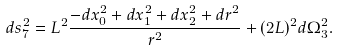Convert formula to latex. <formula><loc_0><loc_0><loc_500><loc_500>d s _ { 7 } ^ { 2 } = L ^ { 2 } \frac { - d x _ { 0 } ^ { 2 } + d x _ { 1 } ^ { 2 } + d x _ { 2 } ^ { 2 } + d r ^ { 2 } } { r ^ { 2 } } + ( 2 L ) ^ { 2 } d \Omega _ { 3 } ^ { 2 } .</formula> 